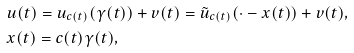Convert formula to latex. <formula><loc_0><loc_0><loc_500><loc_500>& u ( t ) = u _ { c ( t ) } ( \gamma ( t ) ) + v ( t ) = \tilde { u } _ { c ( t ) } ( \cdot - x ( t ) ) + v ( t ) , \\ & x ( t ) = c ( t ) \gamma ( t ) ,</formula> 